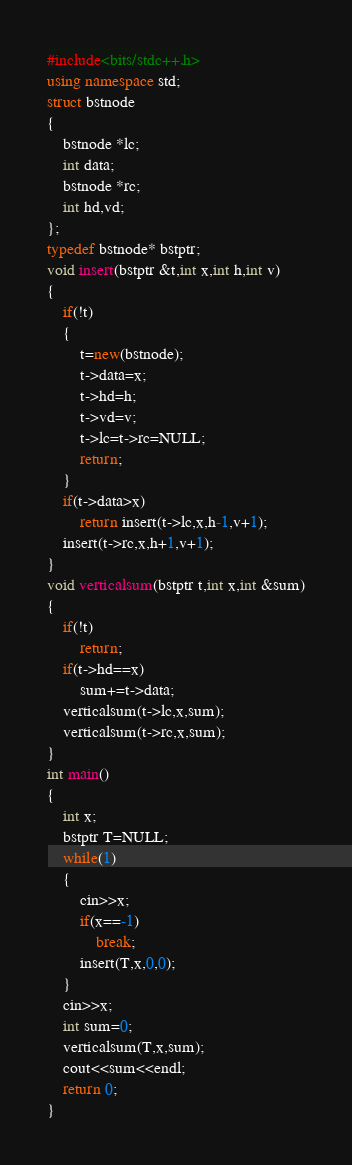Convert code to text. <code><loc_0><loc_0><loc_500><loc_500><_C++_>#include<bits/stdc++.h>
using namespace std;
struct bstnode
{
	bstnode *lc;
	int data;
	bstnode *rc;
	int hd,vd;
};
typedef bstnode* bstptr;
void insert(bstptr &t,int x,int h,int v)
{
	if(!t)
	{
		t=new(bstnode);
		t->data=x;
		t->hd=h;
		t->vd=v;
		t->lc=t->rc=NULL;
		return;
	}
	if(t->data>x)
		return insert(t->lc,x,h-1,v+1);
	insert(t->rc,x,h+1,v+1);
}
void verticalsum(bstptr t,int x,int &sum)
{
	if(!t)
		return;
	if(t->hd==x)
		sum+=t->data;
	verticalsum(t->lc,x,sum);
	verticalsum(t->rc,x,sum);
}
int main()
{
	int x;
	bstptr T=NULL;
	while(1)
	{
		cin>>x;
		if(x==-1)
			break;
		insert(T,x,0,0);
	}
	cin>>x;
	int sum=0;
	verticalsum(T,x,sum);
	cout<<sum<<endl;
	return 0;
}</code> 